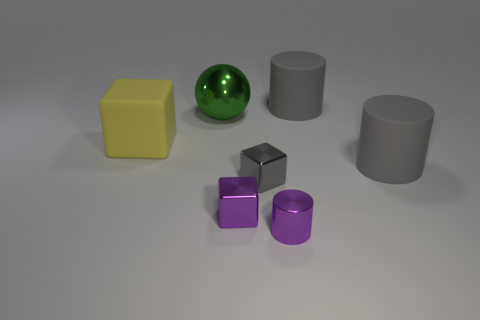There is a small cube that is to the left of the small gray cube; does it have the same color as the tiny shiny cylinder?
Offer a terse response. Yes. Do the matte cylinder that is behind the big metallic thing and the matte object in front of the yellow matte cube have the same color?
Offer a very short reply. Yes. There is a gray block; is its size the same as the gray matte thing that is in front of the matte cube?
Your answer should be compact. No. Is the number of big gray objects that are in front of the yellow matte thing the same as the number of small metallic cubes that are on the left side of the purple cube?
Make the answer very short. No. What number of tiny blocks have the same color as the shiny cylinder?
Your answer should be very brief. 1. What material is the small object that is the same color as the tiny metal cylinder?
Make the answer very short. Metal. How many shiny objects are either yellow balls or tiny cylinders?
Offer a very short reply. 1. Does the thing on the left side of the big ball have the same shape as the gray rubber thing that is behind the green ball?
Keep it short and to the point. No. How many gray rubber things are in front of the large green sphere?
Your answer should be very brief. 1. Are there any other spheres that have the same material as the ball?
Keep it short and to the point. No. 